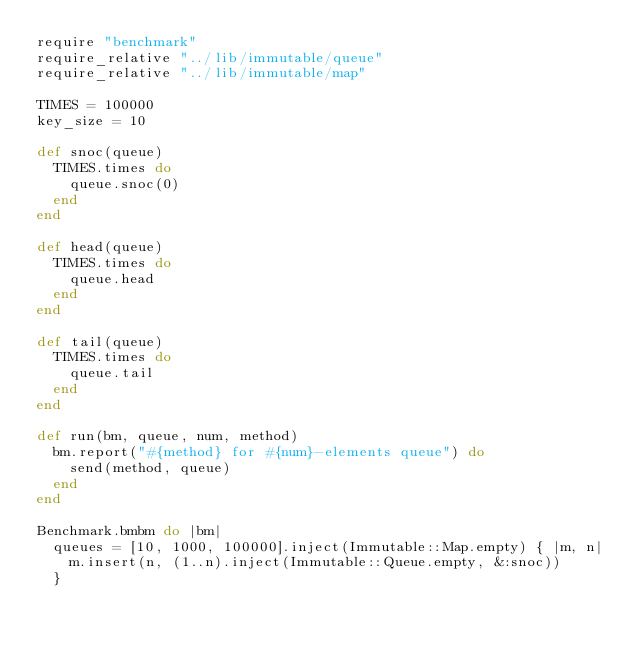<code> <loc_0><loc_0><loc_500><loc_500><_Ruby_>require "benchmark"
require_relative "../lib/immutable/queue"
require_relative "../lib/immutable/map"

TIMES = 100000
key_size = 10

def snoc(queue)
  TIMES.times do
    queue.snoc(0)
  end
end

def head(queue)
  TIMES.times do
    queue.head
  end
end

def tail(queue)
  TIMES.times do
    queue.tail
  end
end

def run(bm, queue, num, method)
  bm.report("#{method} for #{num}-elements queue") do
    send(method, queue)
  end
end

Benchmark.bmbm do |bm|
  queues = [10, 1000, 100000].inject(Immutable::Map.empty) { |m, n|
    m.insert(n, (1..n).inject(Immutable::Queue.empty, &:snoc))
  }</code> 